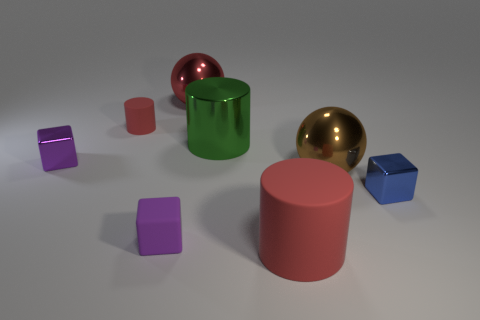Subtract all shiny blocks. How many blocks are left? 1 Subtract all yellow cubes. How many red cylinders are left? 2 Subtract all green cylinders. How many cylinders are left? 2 Subtract 1 cylinders. How many cylinders are left? 2 Subtract all yellow blocks. Subtract all purple cylinders. How many blocks are left? 3 Add 2 shiny blocks. How many objects exist? 10 Subtract all cubes. How many objects are left? 5 Subtract all tiny blue rubber cylinders. Subtract all purple metal things. How many objects are left? 7 Add 3 big brown objects. How many big brown objects are left? 4 Add 7 tiny balls. How many tiny balls exist? 7 